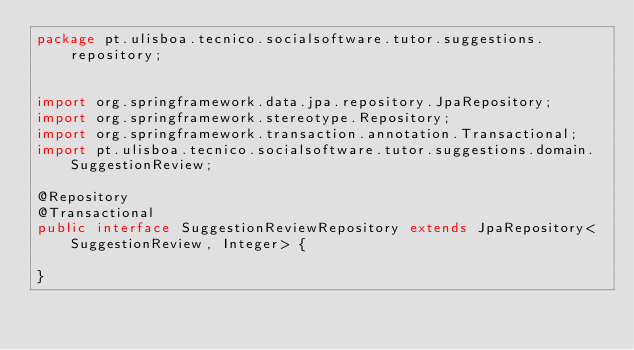Convert code to text. <code><loc_0><loc_0><loc_500><loc_500><_Java_>package pt.ulisboa.tecnico.socialsoftware.tutor.suggestions.repository;


import org.springframework.data.jpa.repository.JpaRepository;
import org.springframework.stereotype.Repository;
import org.springframework.transaction.annotation.Transactional;
import pt.ulisboa.tecnico.socialsoftware.tutor.suggestions.domain.SuggestionReview;

@Repository
@Transactional
public interface SuggestionReviewRepository extends JpaRepository<SuggestionReview, Integer> {

}</code> 